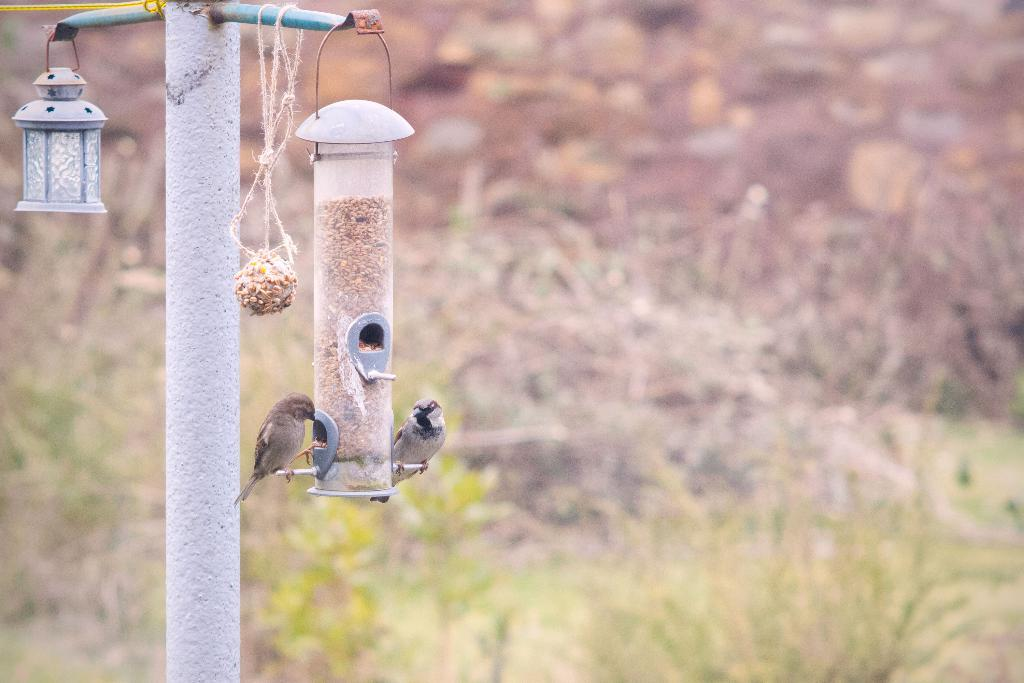What animals can be seen in the image? There are birds on a bird feeding station in the image. What can be seen in the background of the image? There are plants in the background of the image. What is the name of the daughter in the image? There is no daughter present in the image; it features birds on a bird feeding station and plants in the background. 